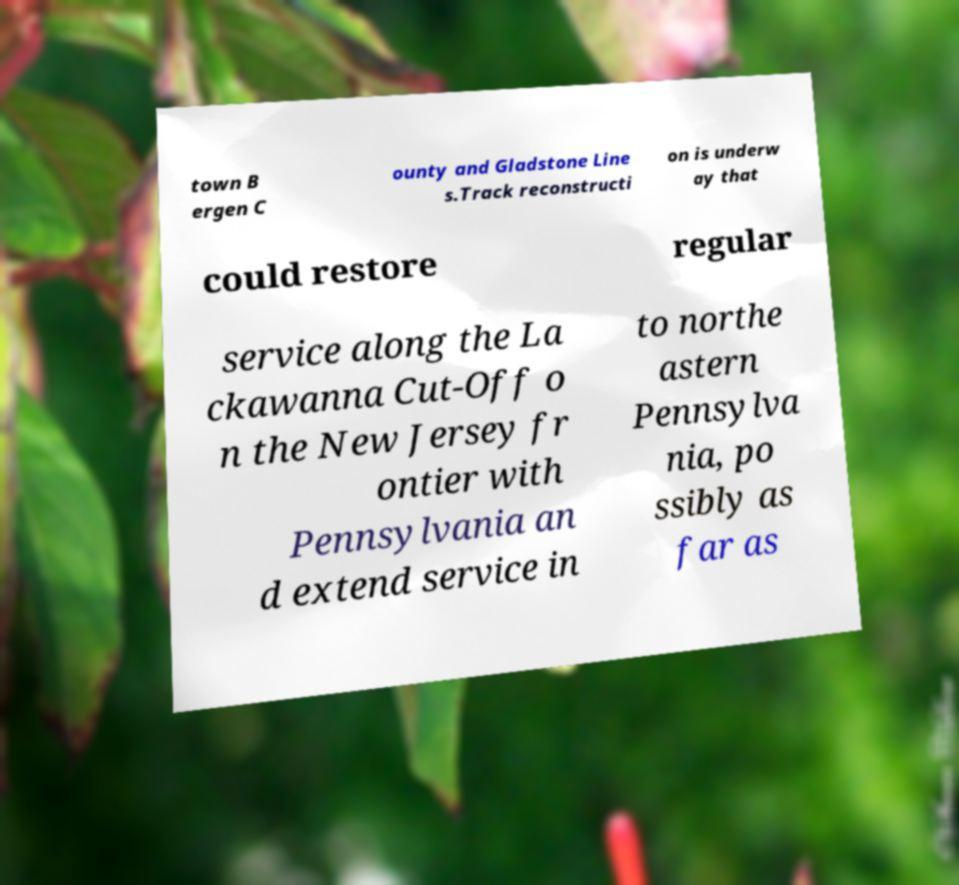Could you assist in decoding the text presented in this image and type it out clearly? town B ergen C ounty and Gladstone Line s.Track reconstructi on is underw ay that could restore regular service along the La ckawanna Cut-Off o n the New Jersey fr ontier with Pennsylvania an d extend service in to northe astern Pennsylva nia, po ssibly as far as 